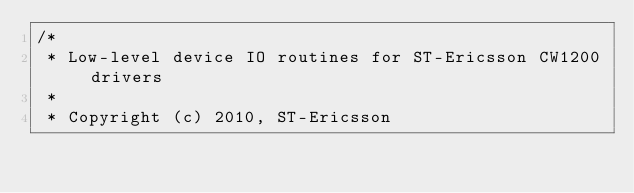<code> <loc_0><loc_0><loc_500><loc_500><_C_>/*
 * Low-level device IO routines for ST-Ericsson CW1200 drivers
 *
 * Copyright (c) 2010, ST-Ericsson</code> 